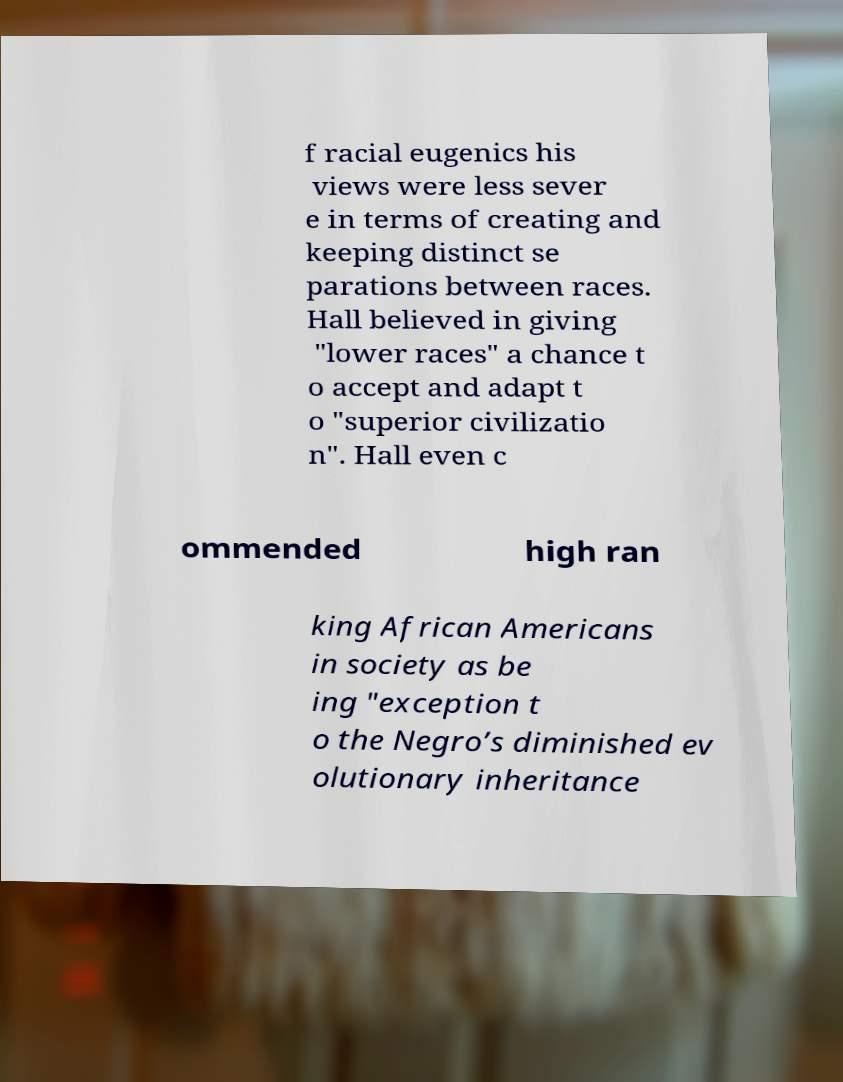What messages or text are displayed in this image? I need them in a readable, typed format. f racial eugenics his views were less sever e in terms of creating and keeping distinct se parations between races. Hall believed in giving "lower races" a chance t o accept and adapt t o "superior civilizatio n". Hall even c ommended high ran king African Americans in society as be ing "exception t o the Negro’s diminished ev olutionary inheritance 